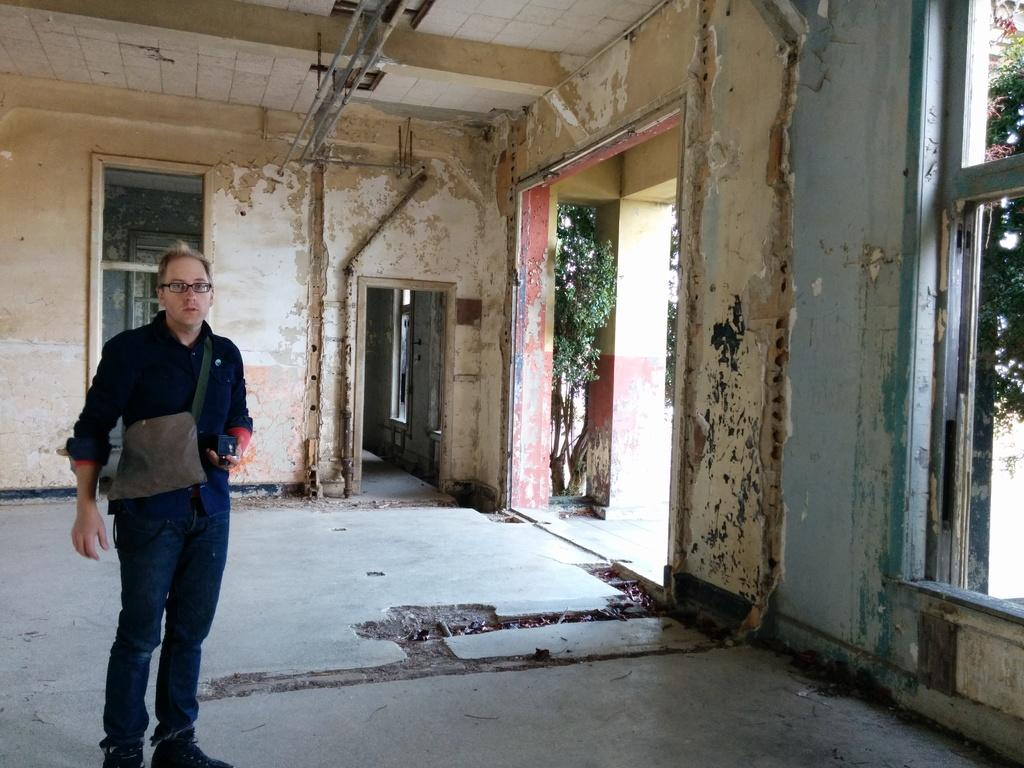What is present in the image? There is a person in the image. What is the person doing in the image? The person is holding an object. What can be seen in the distance in the image? There are trees in the background of the image. What type of club does the person use to interact with the trees in the image? There is no club present in the image, and the person is not interacting with the trees. 